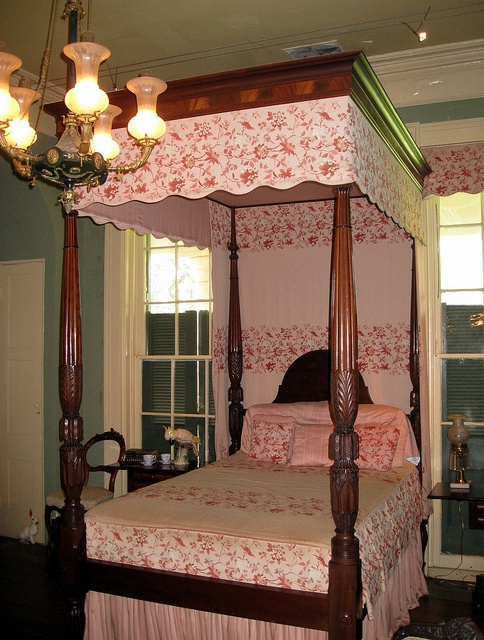Describe the objects in this image and their specific colors. I can see bed in darkgreen, gray, black, and tan tones and chair in darkgreen, black, and gray tones in this image. 